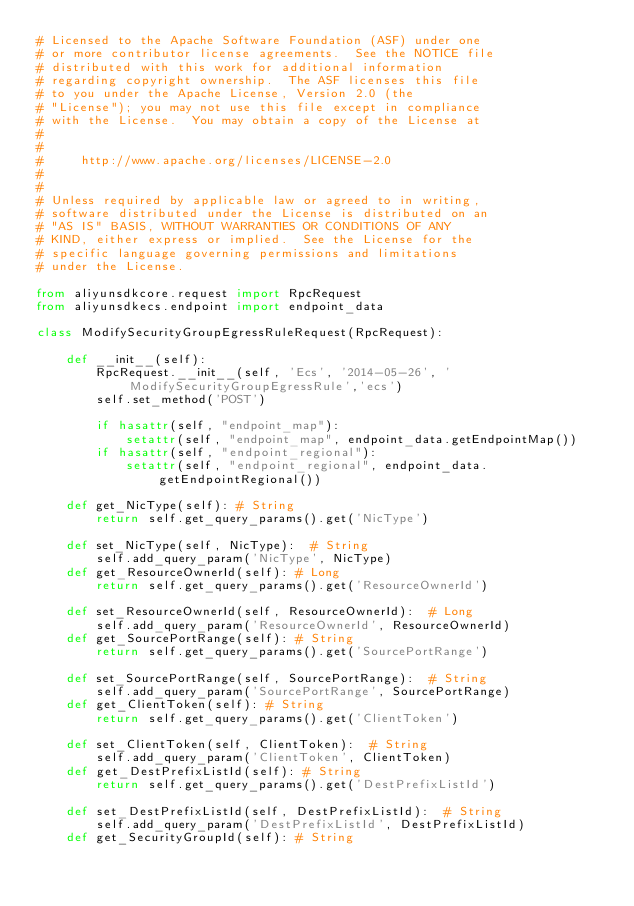<code> <loc_0><loc_0><loc_500><loc_500><_Python_># Licensed to the Apache Software Foundation (ASF) under one
# or more contributor license agreements.  See the NOTICE file
# distributed with this work for additional information
# regarding copyright ownership.  The ASF licenses this file
# to you under the Apache License, Version 2.0 (the
# "License"); you may not use this file except in compliance
# with the License.  You may obtain a copy of the License at
#
#
#     http://www.apache.org/licenses/LICENSE-2.0
#
#
# Unless required by applicable law or agreed to in writing,
# software distributed under the License is distributed on an
# "AS IS" BASIS, WITHOUT WARRANTIES OR CONDITIONS OF ANY
# KIND, either express or implied.  See the License for the
# specific language governing permissions and limitations
# under the License.

from aliyunsdkcore.request import RpcRequest
from aliyunsdkecs.endpoint import endpoint_data

class ModifySecurityGroupEgressRuleRequest(RpcRequest):

	def __init__(self):
		RpcRequest.__init__(self, 'Ecs', '2014-05-26', 'ModifySecurityGroupEgressRule','ecs')
		self.set_method('POST')

		if hasattr(self, "endpoint_map"):
			setattr(self, "endpoint_map", endpoint_data.getEndpointMap())
		if hasattr(self, "endpoint_regional"):
			setattr(self, "endpoint_regional", endpoint_data.getEndpointRegional())

	def get_NicType(self): # String
		return self.get_query_params().get('NicType')

	def set_NicType(self, NicType):  # String
		self.add_query_param('NicType', NicType)
	def get_ResourceOwnerId(self): # Long
		return self.get_query_params().get('ResourceOwnerId')

	def set_ResourceOwnerId(self, ResourceOwnerId):  # Long
		self.add_query_param('ResourceOwnerId', ResourceOwnerId)
	def get_SourcePortRange(self): # String
		return self.get_query_params().get('SourcePortRange')

	def set_SourcePortRange(self, SourcePortRange):  # String
		self.add_query_param('SourcePortRange', SourcePortRange)
	def get_ClientToken(self): # String
		return self.get_query_params().get('ClientToken')

	def set_ClientToken(self, ClientToken):  # String
		self.add_query_param('ClientToken', ClientToken)
	def get_DestPrefixListId(self): # String
		return self.get_query_params().get('DestPrefixListId')

	def set_DestPrefixListId(self, DestPrefixListId):  # String
		self.add_query_param('DestPrefixListId', DestPrefixListId)
	def get_SecurityGroupId(self): # String</code> 